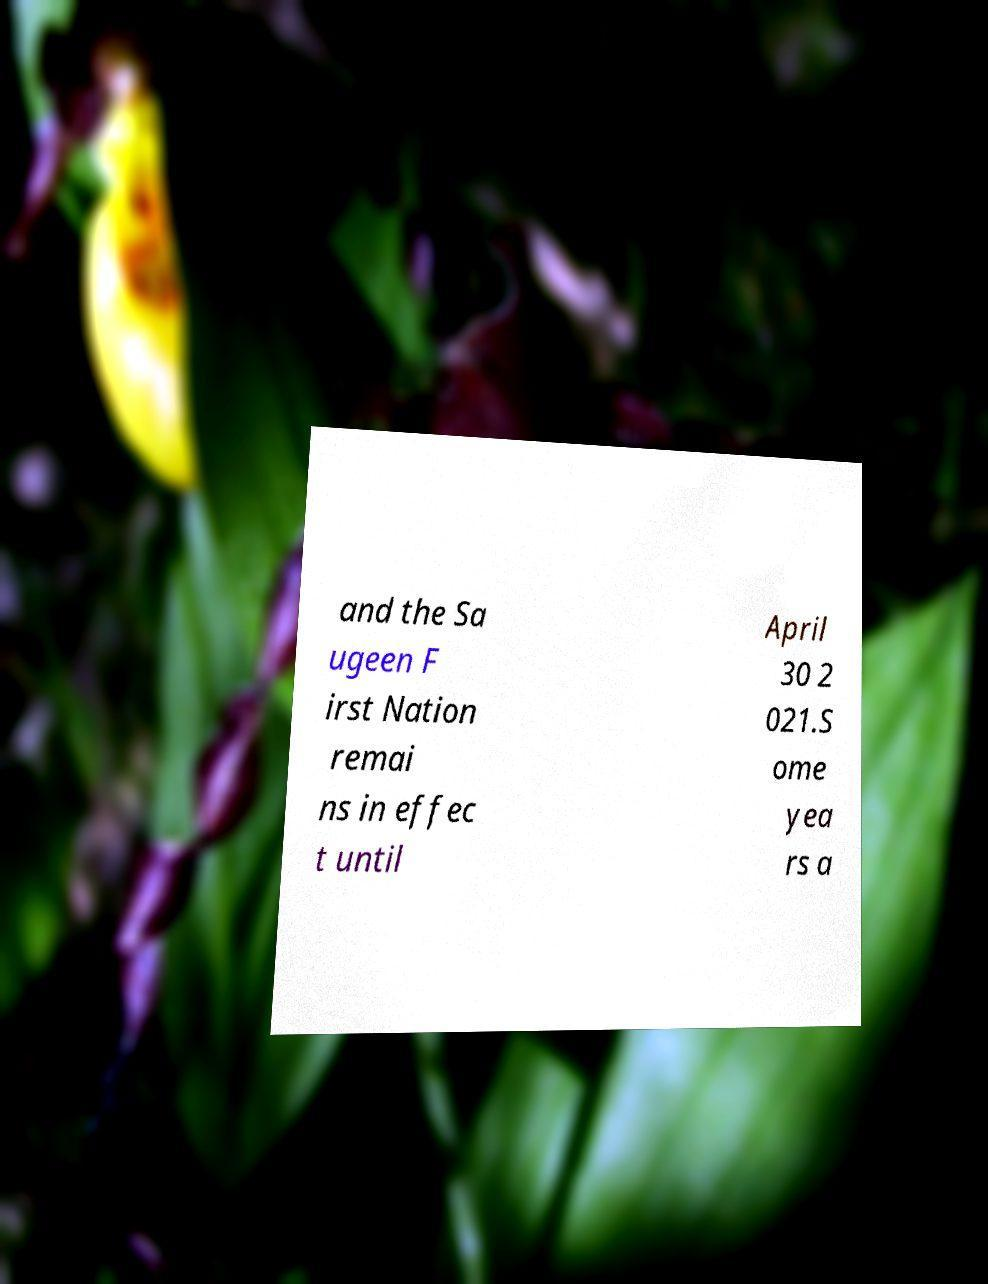Can you accurately transcribe the text from the provided image for me? and the Sa ugeen F irst Nation remai ns in effec t until April 30 2 021.S ome yea rs a 